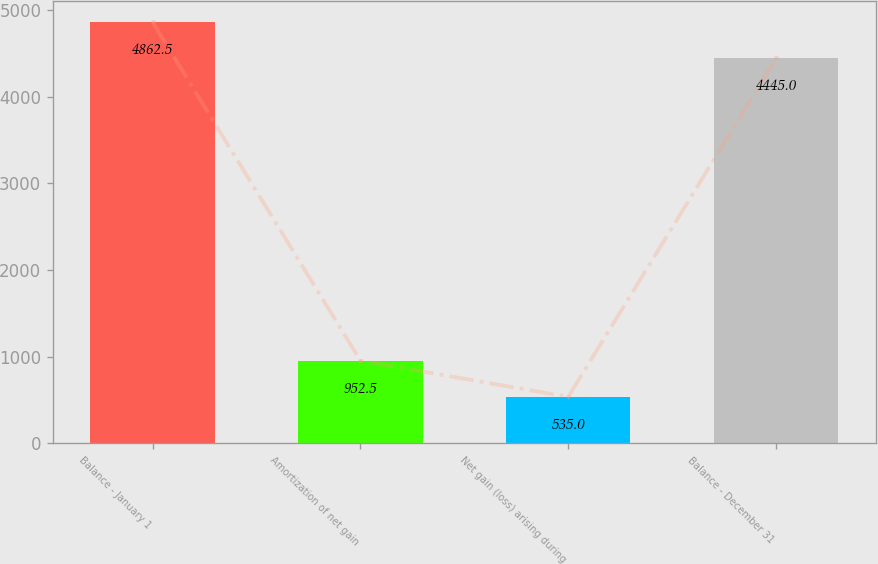<chart> <loc_0><loc_0><loc_500><loc_500><bar_chart><fcel>Balance - January 1<fcel>Amortization of net gain<fcel>Net gain (loss) arising during<fcel>Balance - December 31<nl><fcel>4862.5<fcel>952.5<fcel>535<fcel>4445<nl></chart> 